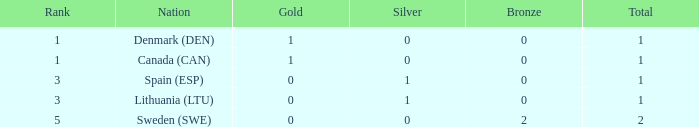What is the rank when there was less than 1 gold, 0 bronze, and more than 1 total? None. 